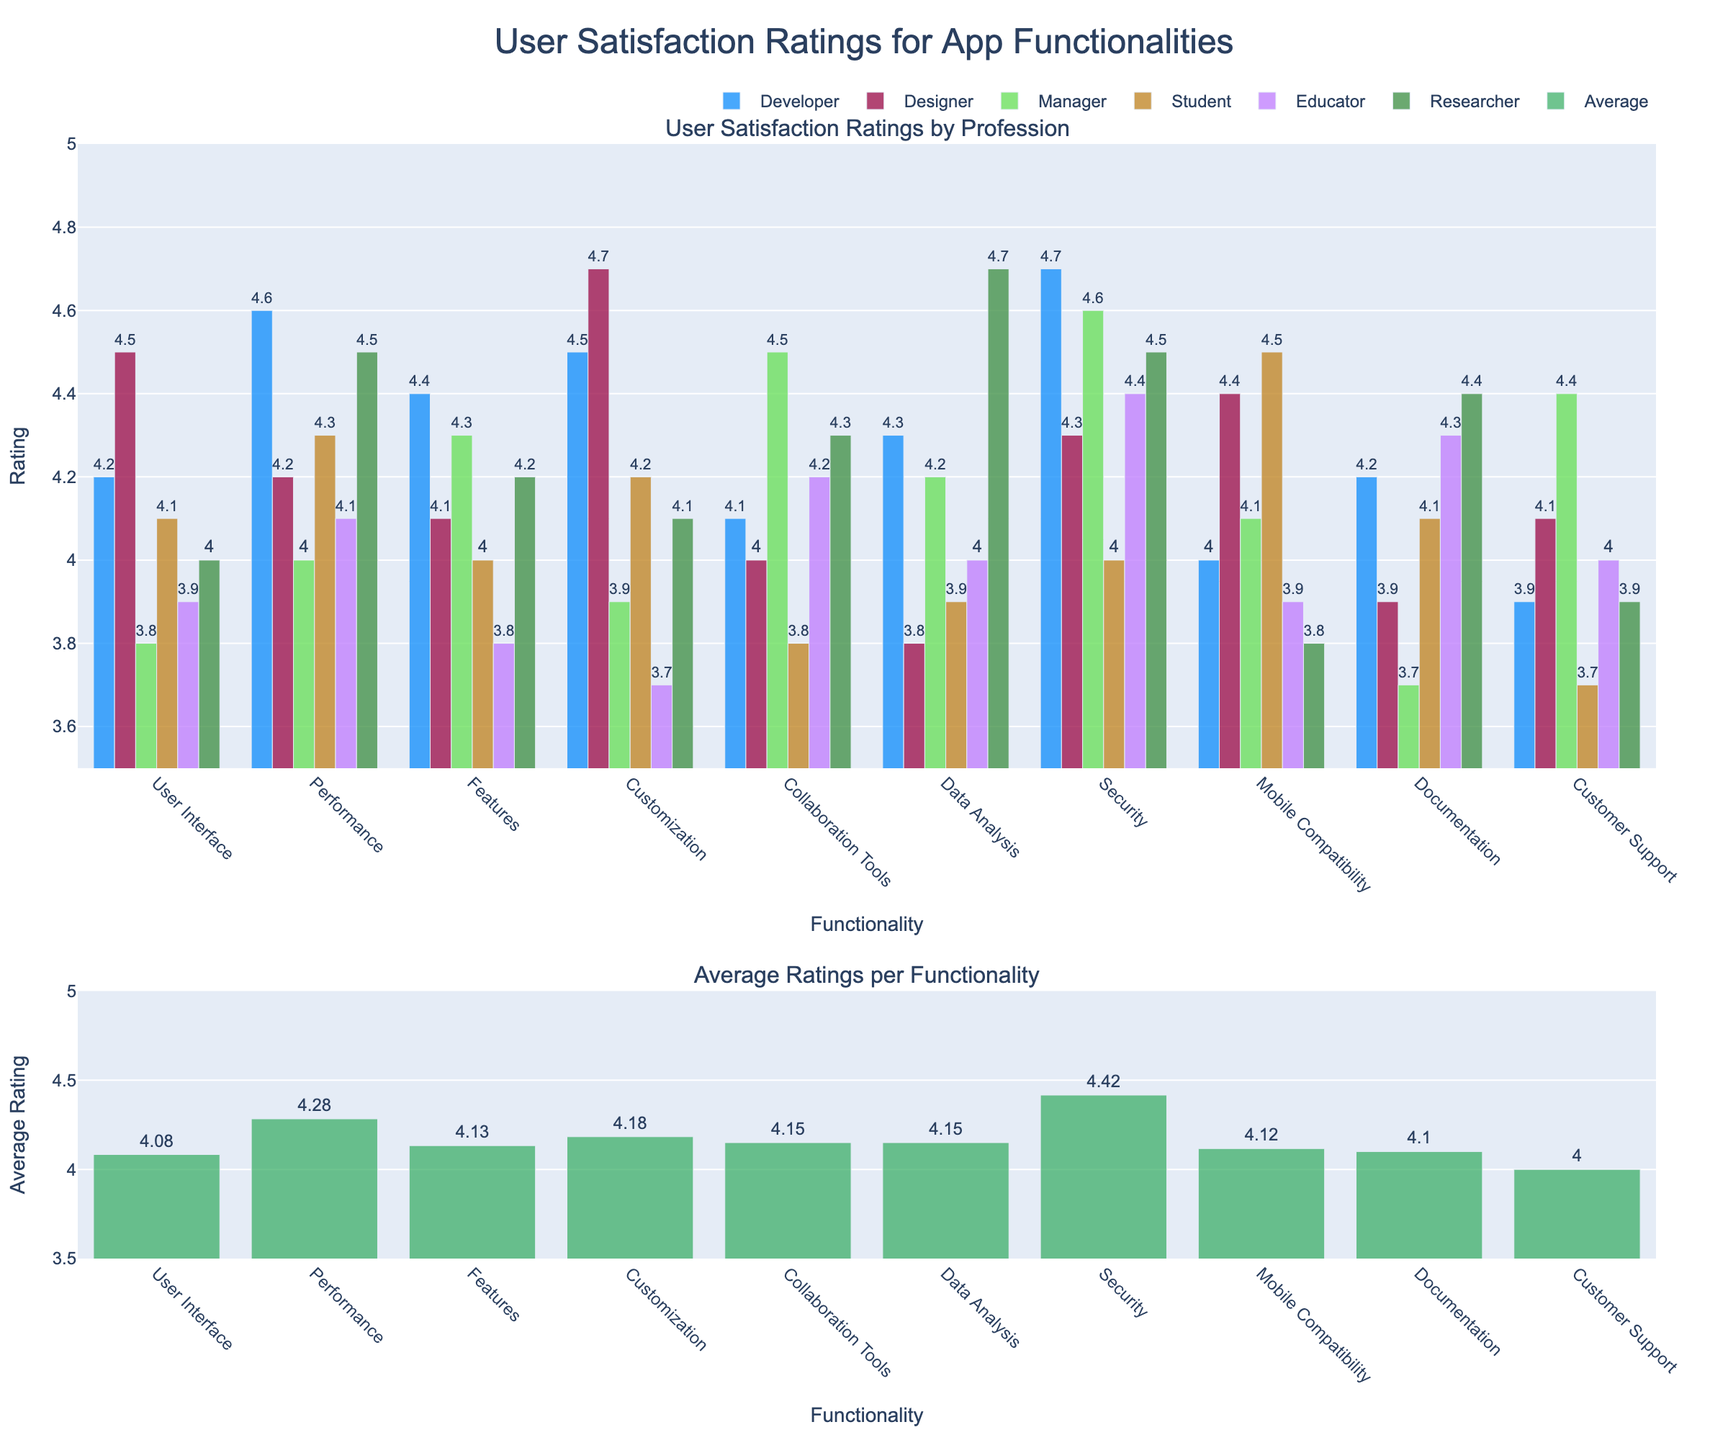what is the median rating for the "Performance" functionality? The ratings for "Performance" by profession are 4.6, 4.2, 4.0, 4.3, 4.1, and 4.5. When sorted, they are 4.0, 4.1, 4.2, 4.3, 4.5, and 4.6. The median is the average of the 3rd and 4th values, which are 4.2 and 4.3. Therefore, the median is (4.2 + 4.3) / 2 = 4.25
Answer: 4.25 Which profession rated "User Interface" the highest? The ratings for "User Interface" show that Designers gave the highest rating of 4.5, which is higher than the ratings from the other professions
Answer: Designers Is the average rating for "Security" higher than the average rating for "Features"? "Security" has the following ratings: 4.7, 4.3, 4.6, 4.0, 4.4, and 4.5. The average is (4.7 + 4.3 + 4.6 + 4.0 + 4.4 + 4.5) / 6 = 4.42. "Features" has ratings: 4.4, 4.1, 4.3, 4.0, 3.8, and 4.2. The average is (4.4 + 4.1 + 4.3 + 4.0 + 3.8 + 4.2) / 6 = 4.13. Thus, 4.42 > 4.13
Answer: Yes Which profession gave the lowest rating for "Collaboration Tools"? The ratings for "Collaboration Tools" by profession are 4.1, 4.0, 4.5, 3.8, 4.2, and 4.3. The lowest rating here is 3.8, given by Students
Answer: Students By how much does the average rating for "Customization" exceed the rating given by Managers for the same functionality? The average rating for "Customization" is calculated as follows: (4.5 + 4.7 + 3.9 + 4.2 + 3.7 + 4.1) / 6 = 4.18. The rating given by Managers is 3.9, so the difference is 4.18 - 3.9 = 0.28
Answer: 0.28 Which functionality received the most consistent ratings across different professions, i.e., smallest range of ratings? To find the consistency, determine the range (difference between highest and lowest rating) for all functionalities. "User Interface" range = 4.5 - 3.8 = 0.7. "Performance" range = 4.6 - 4.0 = 0.6. "Features" range = 4.4 - 3.8 = 0.6. "Customization" range = 4.7 - 3.7 = 1.0. "Collaboration Tools" range = 4.5 - 3.8 = 0.7. "Data Analysis" range = 4.7 - 3.8 = 0.9. "Security" range = 4.7 - 4.0 = 0.7. "Mobile Compatibility" range = 4.5 - 3.8 = 0.7. "Documentation" range = 4.4 - 3.7 = 0.7. "Customer Support" range = 4.4 - 3.7 = 0.7. "Performance" and "Features" are the most consistent with a range of 0.6
Answer: Performance/Features What is the sum of average ratings for "Customer Support" and "Documentation"? The average rating for "Customer Support" is (3.9 + 4.1 + 4.4 + 3.7 + 4.0 + 3.9) / 6 = 4.00. The average rating for "Documentation" is (4.2 + 3.9 + 3.7 + 4.1 + 4.3 + 4.4) / 6 = 4.10. The sum is 4.00 + 4.10 = 8.10
Answer: 8.10 